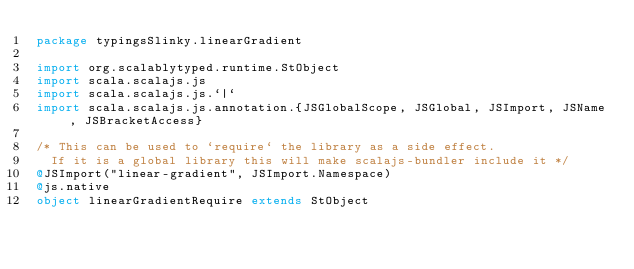<code> <loc_0><loc_0><loc_500><loc_500><_Scala_>package typingsSlinky.linearGradient

import org.scalablytyped.runtime.StObject
import scala.scalajs.js
import scala.scalajs.js.`|`
import scala.scalajs.js.annotation.{JSGlobalScope, JSGlobal, JSImport, JSName, JSBracketAccess}

/* This can be used to `require` the library as a side effect.
  If it is a global library this will make scalajs-bundler include it */
@JSImport("linear-gradient", JSImport.Namespace)
@js.native
object linearGradientRequire extends StObject
</code> 